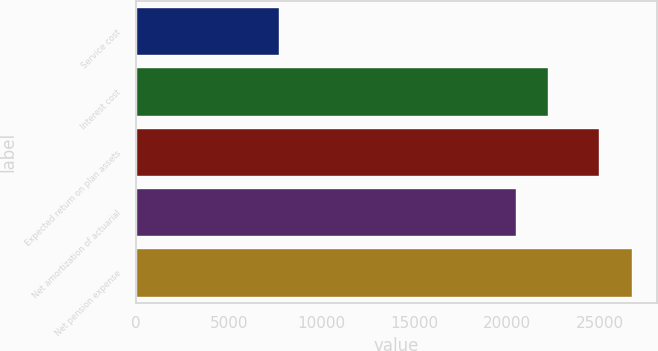Convert chart to OTSL. <chart><loc_0><loc_0><loc_500><loc_500><bar_chart><fcel>Service cost<fcel>Interest cost<fcel>Expected return on plan assets<fcel>Net amortization of actuarial<fcel>Net pension expense<nl><fcel>7714<fcel>22206.4<fcel>24951<fcel>20454<fcel>26703.4<nl></chart> 